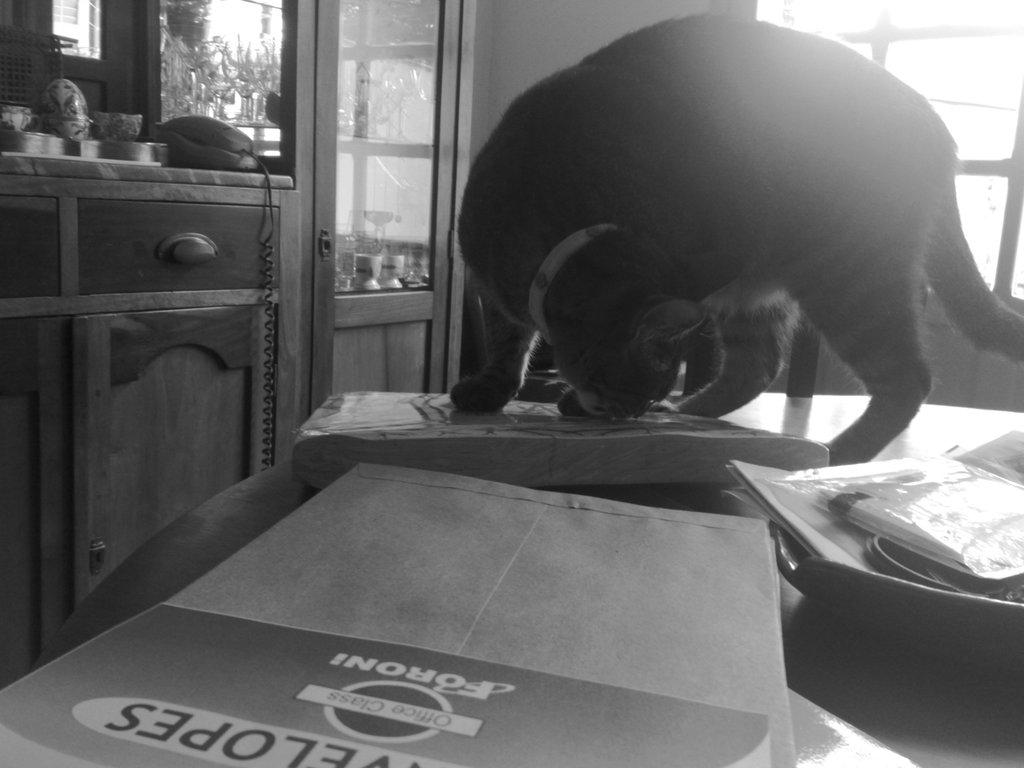What animal is on the table in the image? There is a cat on the table in the image. What objects are visible behind the cat? There are glasses and cupboards behind the cat. What feature of the room is visible behind the cat? There is a window behind the cat. What type of skirt is hanging on the window in the image? There is no skirt present in the image; the window is visible behind the cat, but there is no clothing item hanging on it. 